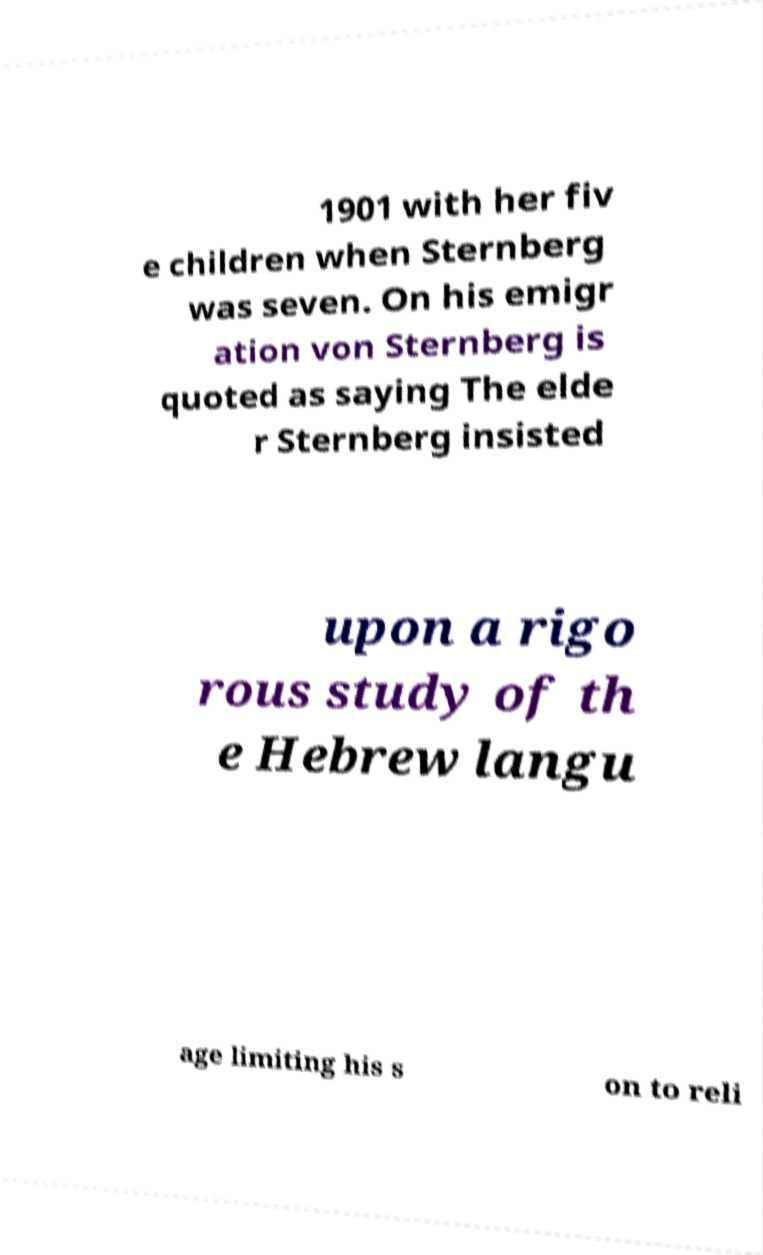For documentation purposes, I need the text within this image transcribed. Could you provide that? 1901 with her fiv e children when Sternberg was seven. On his emigr ation von Sternberg is quoted as saying The elde r Sternberg insisted upon a rigo rous study of th e Hebrew langu age limiting his s on to reli 